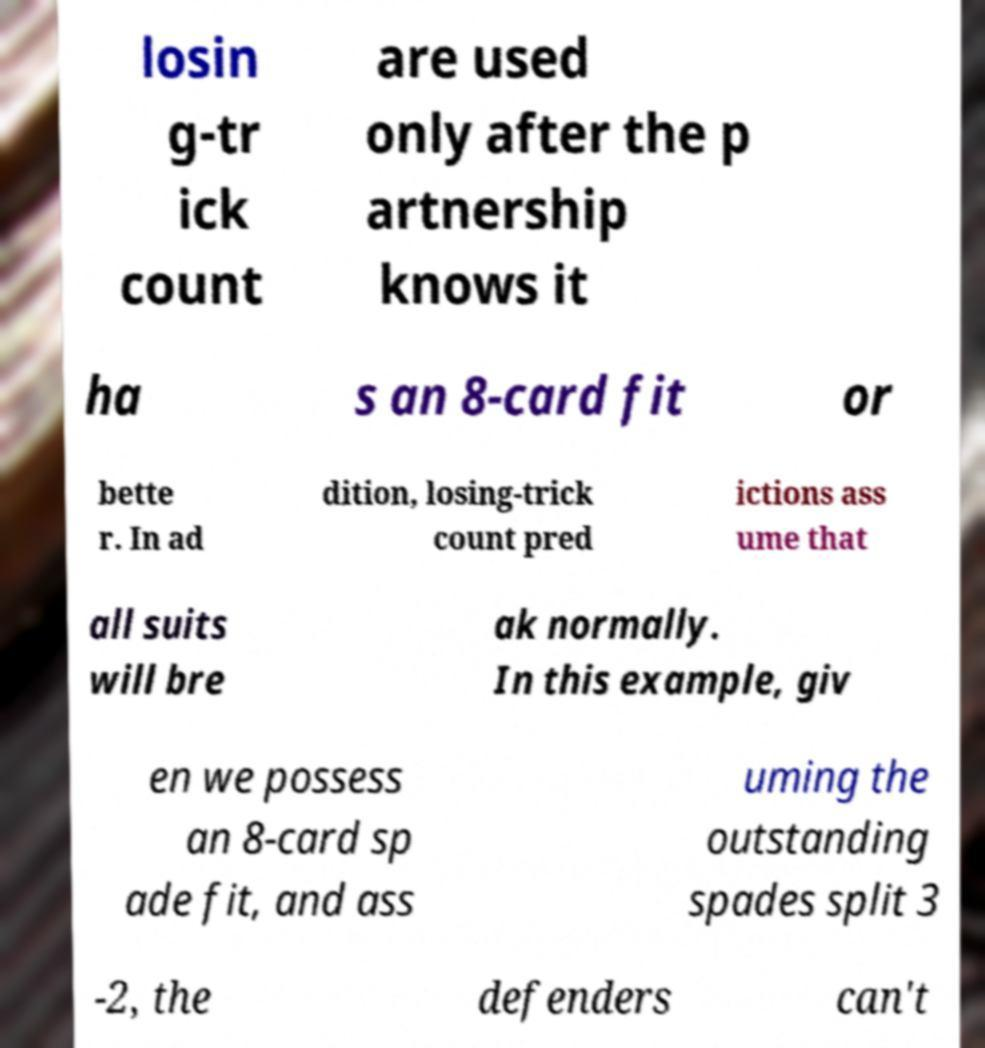Please read and relay the text visible in this image. What does it say? losin g-tr ick count are used only after the p artnership knows it ha s an 8-card fit or bette r. In ad dition, losing-trick count pred ictions ass ume that all suits will bre ak normally. In this example, giv en we possess an 8-card sp ade fit, and ass uming the outstanding spades split 3 -2, the defenders can't 